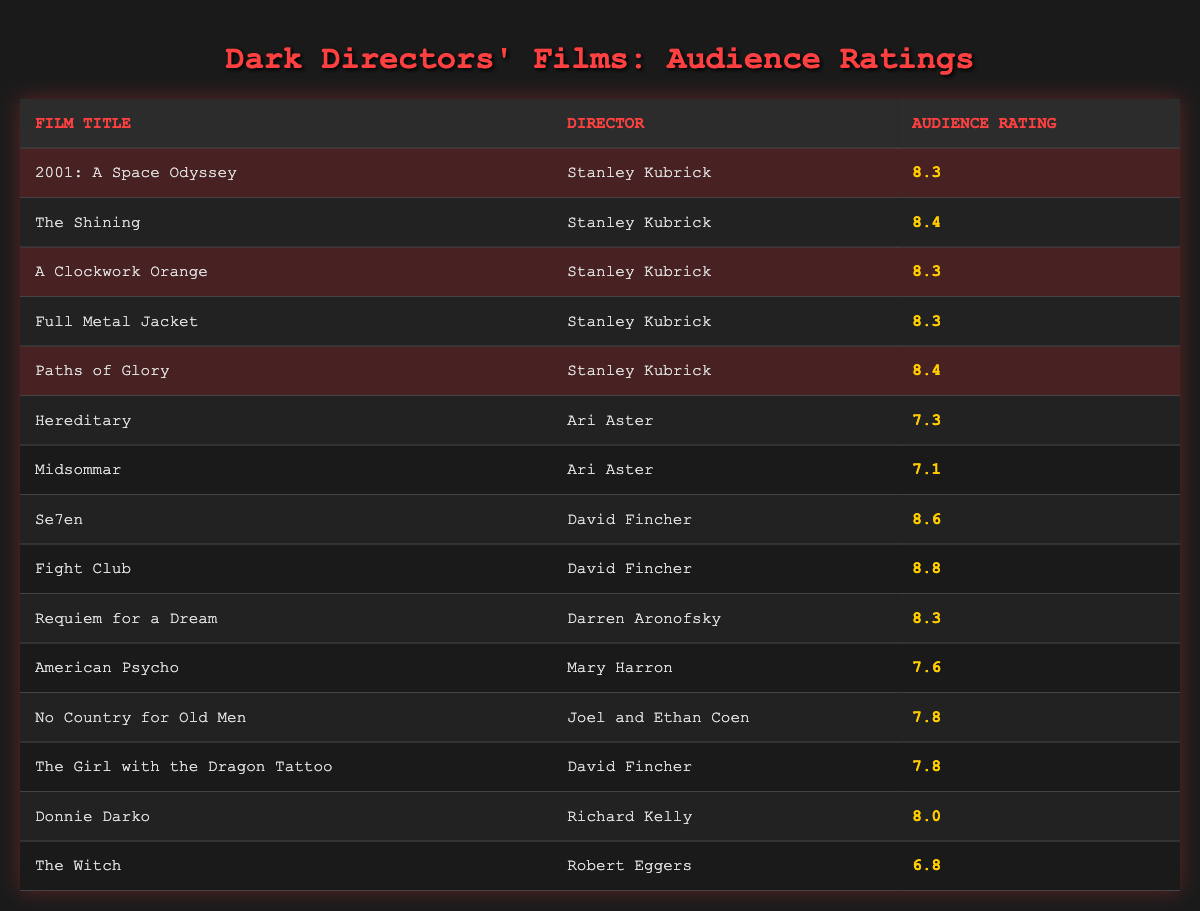What is the audience rating of "The Shining"? The table lists "The Shining" under Stanley Kubrick's films with an audience rating of 8.4.
Answer: 8.4 Which film has the highest audience rating among the listed films? Among the films, "Fight Club" directed by David Fincher has the highest audience rating of 8.8.
Answer: Fight Club Is the audience rating of "Hereditary" higher than that of "A Clockwork Orange"? "Hereditary" has an audience rating of 7.3, while "A Clockwork Orange" has a rating of 8.3. Since 7.3 is less than 8.3, the statement is false.
Answer: No What is the average audience rating for the films directed by Stanley Kubrick? The audience ratings for Kubrick's films are 8.3, 8.4, 8.3, 8.3, and 8.4. To find the average, calculate the sum: (8.3 + 8.4 + 8.3 + 8.3 + 8.4) = 41.6. Then divide by 5 (the number of films): 41.6 / 5 = 8.32.
Answer: 8.32 Do more films directed by David Fincher have audience ratings above 8.0 compared to Stanley Kubrick's films? Kubrick has 5 films, all with ratings above 8.0 (8.3, 8.4). Fincher has 2 films above 8.0: "Se7en" (8.6) and "Fight Club" (8.8). Since Kubrick has more than Fincher with ratings above 8.0, the statement is false.
Answer: No 